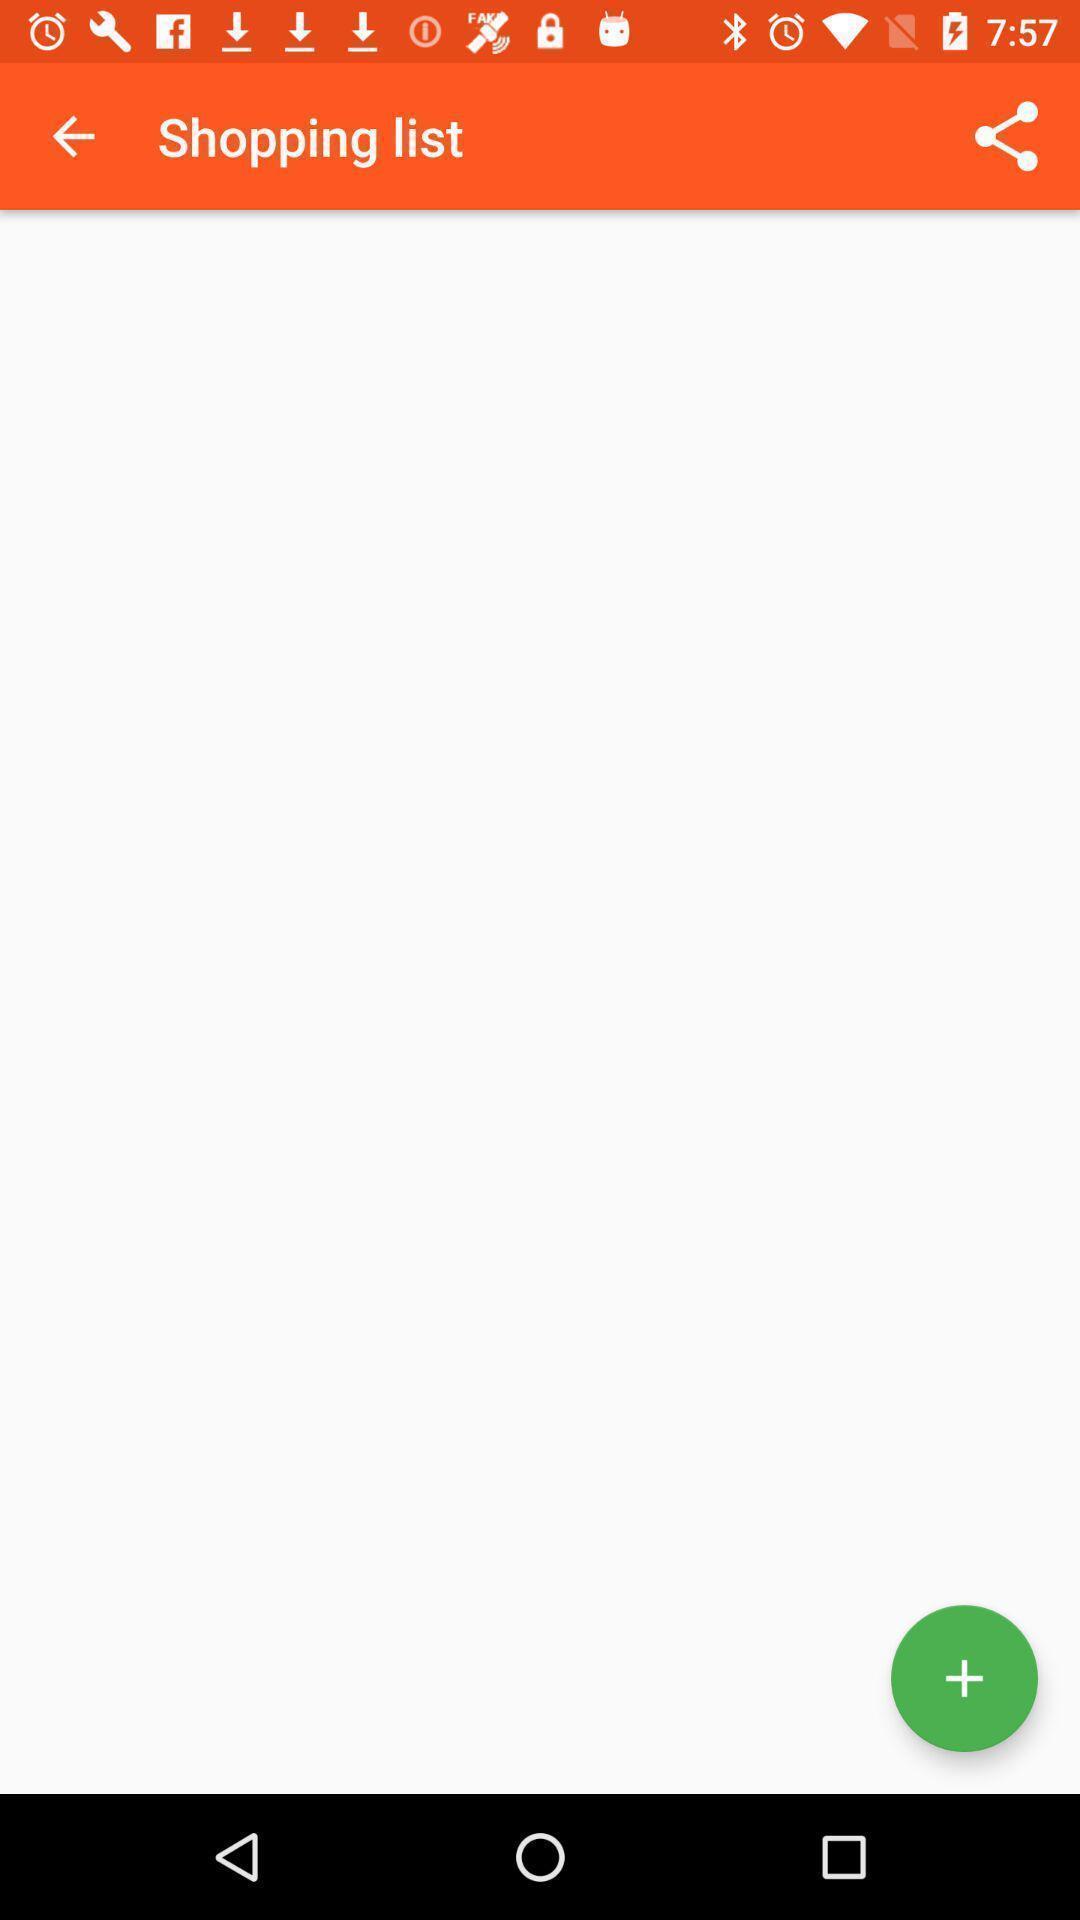Give me a narrative description of this picture. Shopping list page of a shopping application. 